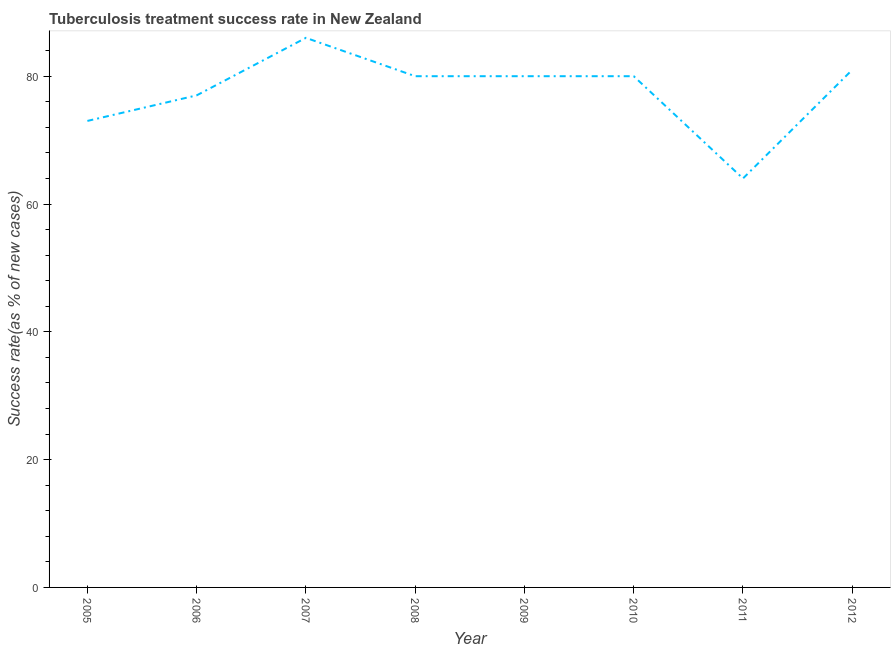What is the tuberculosis treatment success rate in 2008?
Your response must be concise. 80. Across all years, what is the maximum tuberculosis treatment success rate?
Offer a terse response. 86. Across all years, what is the minimum tuberculosis treatment success rate?
Ensure brevity in your answer.  64. In which year was the tuberculosis treatment success rate minimum?
Offer a very short reply. 2011. What is the sum of the tuberculosis treatment success rate?
Keep it short and to the point. 621. What is the difference between the tuberculosis treatment success rate in 2008 and 2012?
Provide a succinct answer. -1. What is the average tuberculosis treatment success rate per year?
Offer a very short reply. 77.62. What is the median tuberculosis treatment success rate?
Ensure brevity in your answer.  80. What is the ratio of the tuberculosis treatment success rate in 2005 to that in 2010?
Ensure brevity in your answer.  0.91. Is the tuberculosis treatment success rate in 2008 less than that in 2010?
Offer a very short reply. No. Is the difference between the tuberculosis treatment success rate in 2006 and 2012 greater than the difference between any two years?
Offer a very short reply. No. What is the difference between the highest and the lowest tuberculosis treatment success rate?
Your response must be concise. 22. Does the tuberculosis treatment success rate monotonically increase over the years?
Your answer should be very brief. No. How many years are there in the graph?
Your answer should be compact. 8. Does the graph contain grids?
Keep it short and to the point. No. What is the title of the graph?
Keep it short and to the point. Tuberculosis treatment success rate in New Zealand. What is the label or title of the Y-axis?
Offer a very short reply. Success rate(as % of new cases). What is the Success rate(as % of new cases) in 2007?
Your answer should be compact. 86. What is the Success rate(as % of new cases) in 2011?
Give a very brief answer. 64. What is the Success rate(as % of new cases) in 2012?
Your answer should be compact. 81. What is the difference between the Success rate(as % of new cases) in 2005 and 2006?
Offer a very short reply. -4. What is the difference between the Success rate(as % of new cases) in 2005 and 2009?
Provide a short and direct response. -7. What is the difference between the Success rate(as % of new cases) in 2006 and 2007?
Your response must be concise. -9. What is the difference between the Success rate(as % of new cases) in 2006 and 2012?
Your answer should be very brief. -4. What is the difference between the Success rate(as % of new cases) in 2007 and 2008?
Provide a short and direct response. 6. What is the difference between the Success rate(as % of new cases) in 2007 and 2009?
Your response must be concise. 6. What is the difference between the Success rate(as % of new cases) in 2007 and 2010?
Keep it short and to the point. 6. What is the difference between the Success rate(as % of new cases) in 2007 and 2011?
Offer a terse response. 22. What is the difference between the Success rate(as % of new cases) in 2007 and 2012?
Offer a terse response. 5. What is the difference between the Success rate(as % of new cases) in 2008 and 2009?
Offer a very short reply. 0. What is the difference between the Success rate(as % of new cases) in 2008 and 2010?
Your response must be concise. 0. What is the difference between the Success rate(as % of new cases) in 2009 and 2010?
Offer a terse response. 0. What is the difference between the Success rate(as % of new cases) in 2009 and 2012?
Make the answer very short. -1. What is the ratio of the Success rate(as % of new cases) in 2005 to that in 2006?
Your response must be concise. 0.95. What is the ratio of the Success rate(as % of new cases) in 2005 to that in 2007?
Make the answer very short. 0.85. What is the ratio of the Success rate(as % of new cases) in 2005 to that in 2008?
Your answer should be compact. 0.91. What is the ratio of the Success rate(as % of new cases) in 2005 to that in 2009?
Provide a short and direct response. 0.91. What is the ratio of the Success rate(as % of new cases) in 2005 to that in 2010?
Keep it short and to the point. 0.91. What is the ratio of the Success rate(as % of new cases) in 2005 to that in 2011?
Provide a short and direct response. 1.14. What is the ratio of the Success rate(as % of new cases) in 2005 to that in 2012?
Keep it short and to the point. 0.9. What is the ratio of the Success rate(as % of new cases) in 2006 to that in 2007?
Your answer should be compact. 0.9. What is the ratio of the Success rate(as % of new cases) in 2006 to that in 2011?
Provide a short and direct response. 1.2. What is the ratio of the Success rate(as % of new cases) in 2006 to that in 2012?
Your response must be concise. 0.95. What is the ratio of the Success rate(as % of new cases) in 2007 to that in 2008?
Keep it short and to the point. 1.07. What is the ratio of the Success rate(as % of new cases) in 2007 to that in 2009?
Offer a very short reply. 1.07. What is the ratio of the Success rate(as % of new cases) in 2007 to that in 2010?
Ensure brevity in your answer.  1.07. What is the ratio of the Success rate(as % of new cases) in 2007 to that in 2011?
Your response must be concise. 1.34. What is the ratio of the Success rate(as % of new cases) in 2007 to that in 2012?
Offer a terse response. 1.06. What is the ratio of the Success rate(as % of new cases) in 2008 to that in 2009?
Offer a very short reply. 1. What is the ratio of the Success rate(as % of new cases) in 2008 to that in 2010?
Ensure brevity in your answer.  1. What is the ratio of the Success rate(as % of new cases) in 2008 to that in 2012?
Your answer should be compact. 0.99. What is the ratio of the Success rate(as % of new cases) in 2009 to that in 2010?
Keep it short and to the point. 1. What is the ratio of the Success rate(as % of new cases) in 2009 to that in 2011?
Provide a succinct answer. 1.25. What is the ratio of the Success rate(as % of new cases) in 2009 to that in 2012?
Make the answer very short. 0.99. What is the ratio of the Success rate(as % of new cases) in 2010 to that in 2012?
Your answer should be very brief. 0.99. What is the ratio of the Success rate(as % of new cases) in 2011 to that in 2012?
Keep it short and to the point. 0.79. 